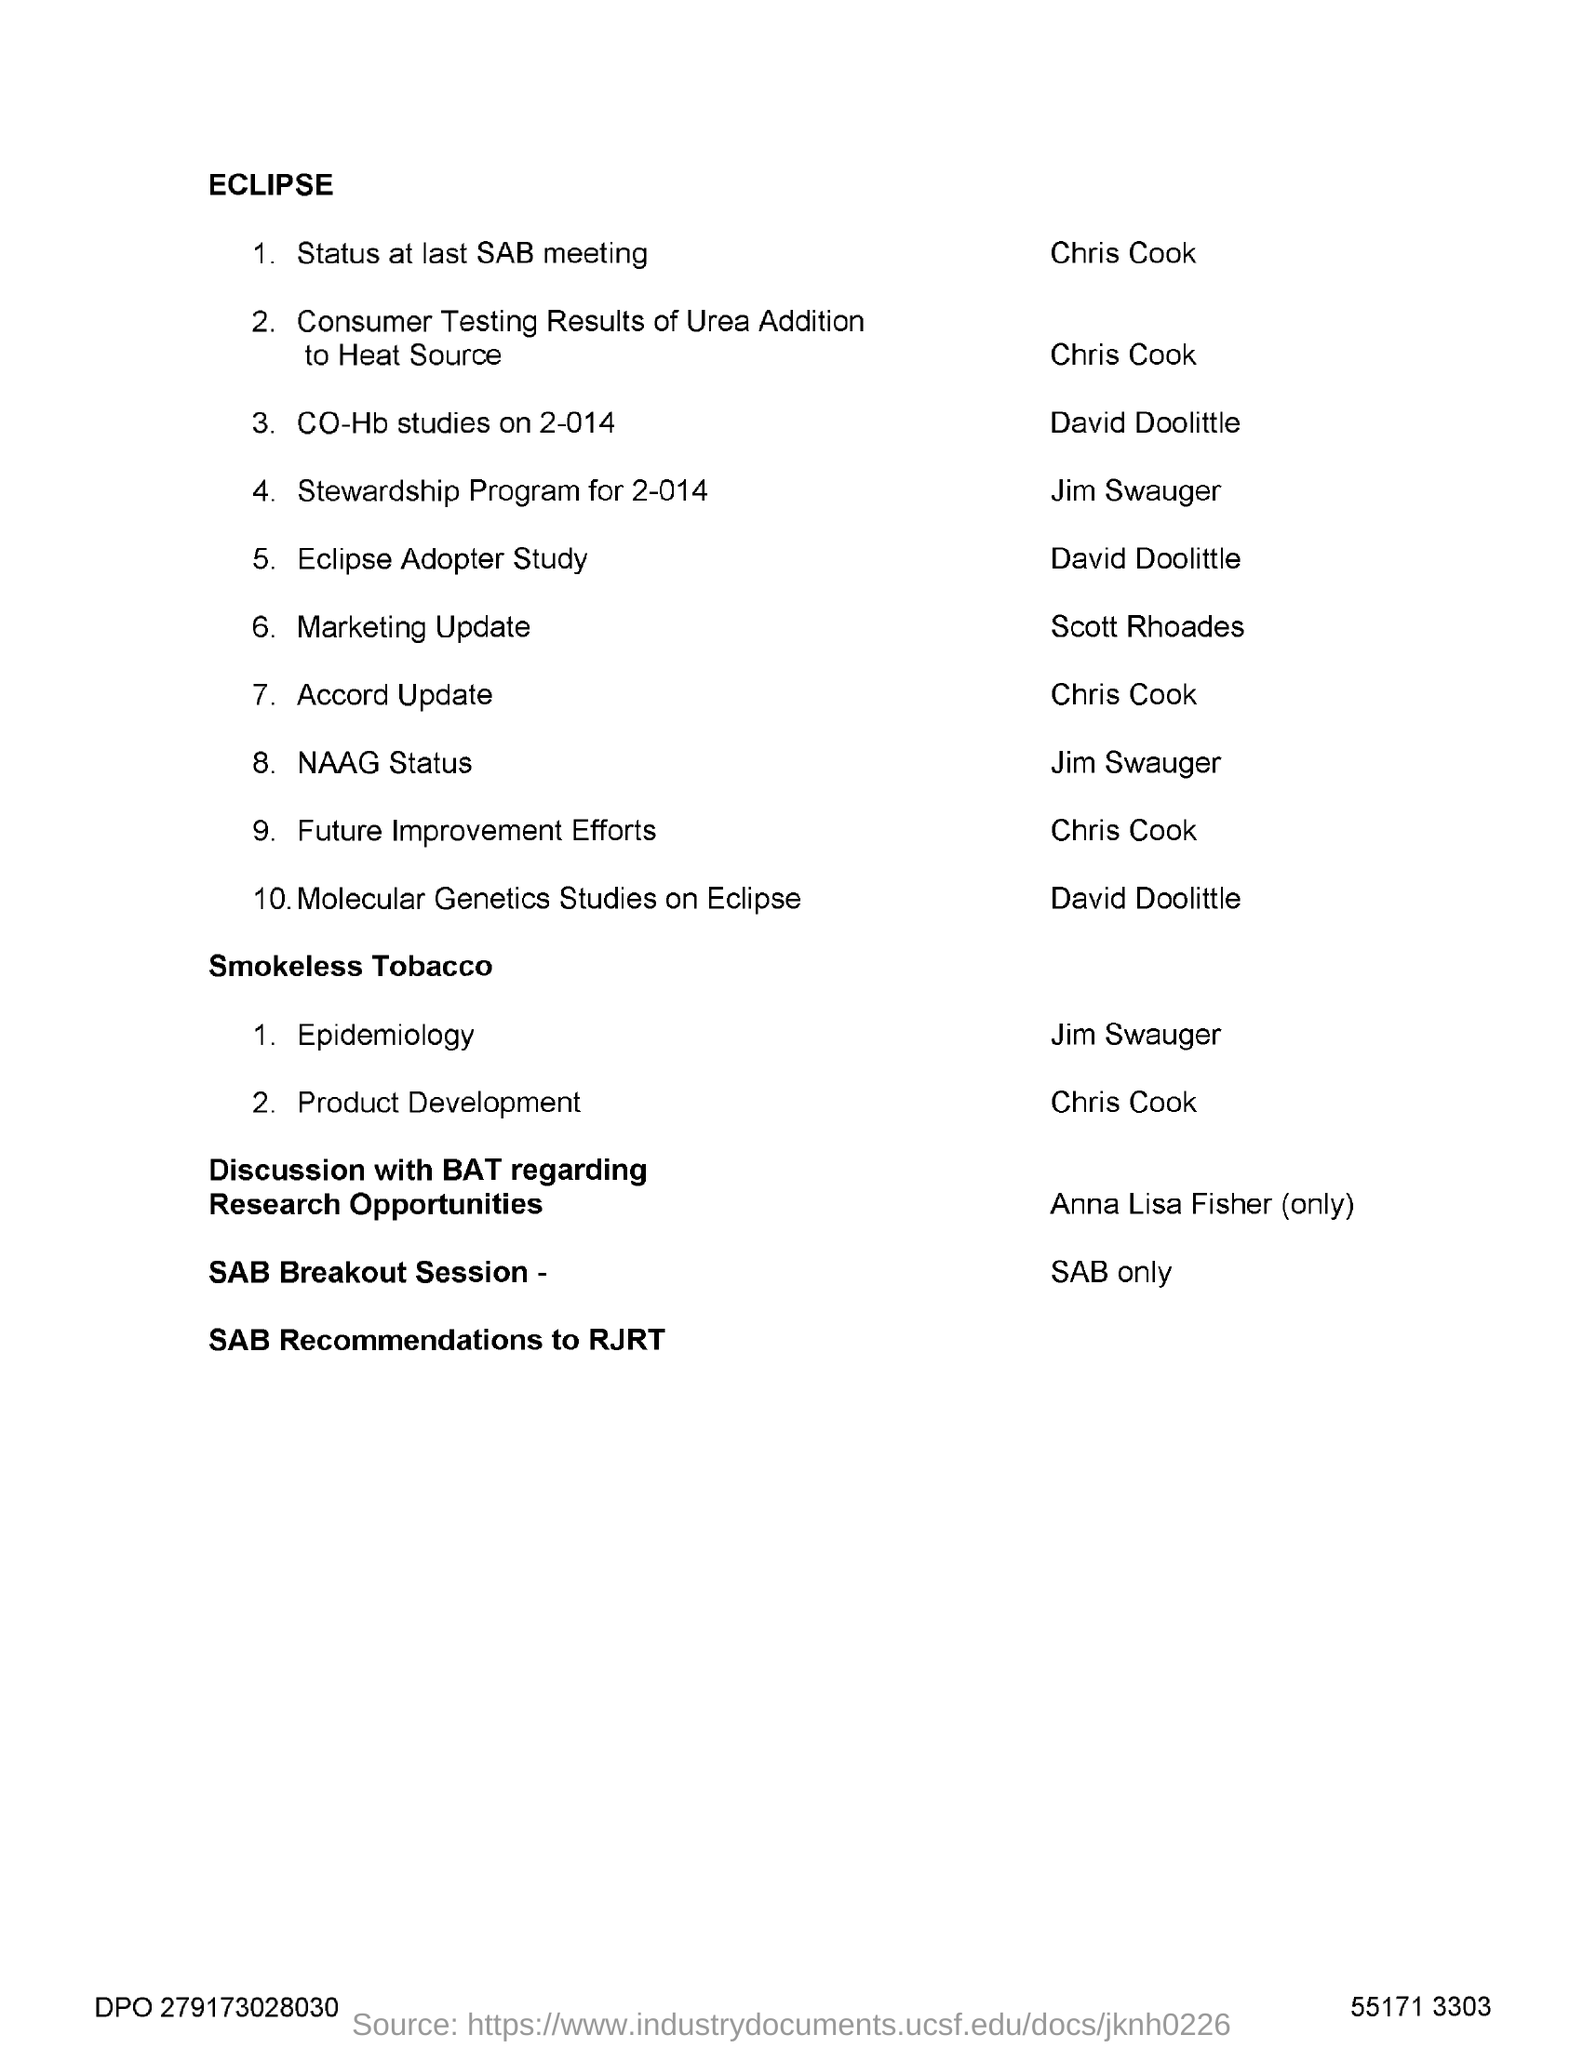Indicate a few pertinent items in this graphic. The title of the document is ECLIPSE. 